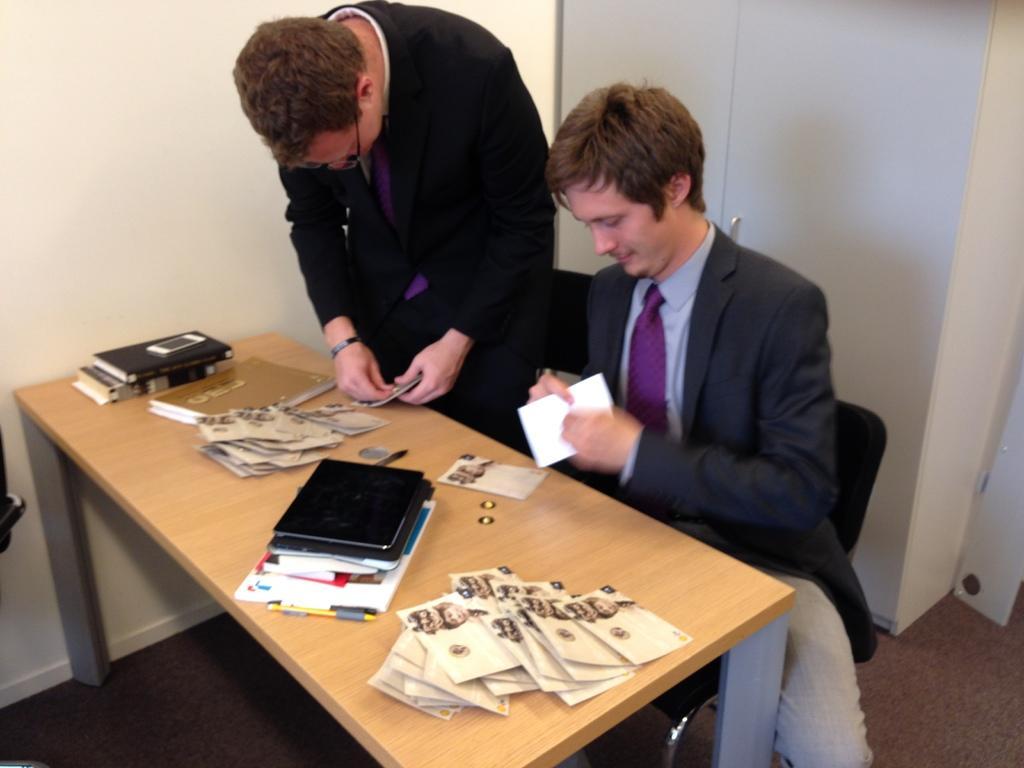Could you give a brief overview of what you see in this image? In this image there are two persons wearing black color suit and at the foreground of the image there is a table on which there are different greeting cards and mobile phone and at the background of the image there is a wardrobe. 